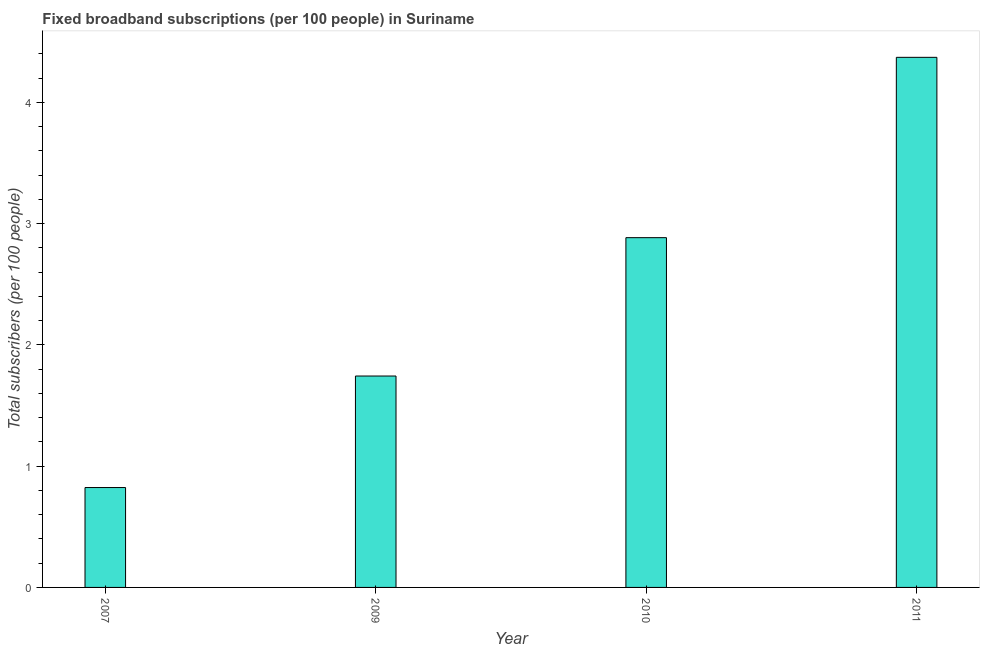Does the graph contain grids?
Your answer should be very brief. No. What is the title of the graph?
Your response must be concise. Fixed broadband subscriptions (per 100 people) in Suriname. What is the label or title of the Y-axis?
Keep it short and to the point. Total subscribers (per 100 people). What is the total number of fixed broadband subscriptions in 2007?
Give a very brief answer. 0.82. Across all years, what is the maximum total number of fixed broadband subscriptions?
Keep it short and to the point. 4.37. Across all years, what is the minimum total number of fixed broadband subscriptions?
Give a very brief answer. 0.82. What is the sum of the total number of fixed broadband subscriptions?
Your response must be concise. 9.82. What is the difference between the total number of fixed broadband subscriptions in 2009 and 2011?
Offer a very short reply. -2.63. What is the average total number of fixed broadband subscriptions per year?
Offer a very short reply. 2.46. What is the median total number of fixed broadband subscriptions?
Your response must be concise. 2.31. In how many years, is the total number of fixed broadband subscriptions greater than 0.6 ?
Give a very brief answer. 4. Do a majority of the years between 2009 and 2011 (inclusive) have total number of fixed broadband subscriptions greater than 1.8 ?
Your answer should be very brief. Yes. What is the ratio of the total number of fixed broadband subscriptions in 2009 to that in 2011?
Ensure brevity in your answer.  0.4. Is the difference between the total number of fixed broadband subscriptions in 2007 and 2010 greater than the difference between any two years?
Provide a succinct answer. No. What is the difference between the highest and the second highest total number of fixed broadband subscriptions?
Your answer should be very brief. 1.49. What is the difference between the highest and the lowest total number of fixed broadband subscriptions?
Your answer should be very brief. 3.55. In how many years, is the total number of fixed broadband subscriptions greater than the average total number of fixed broadband subscriptions taken over all years?
Make the answer very short. 2. Are all the bars in the graph horizontal?
Provide a succinct answer. No. How many years are there in the graph?
Your answer should be very brief. 4. What is the Total subscribers (per 100 people) of 2007?
Keep it short and to the point. 0.82. What is the Total subscribers (per 100 people) of 2009?
Keep it short and to the point. 1.74. What is the Total subscribers (per 100 people) in 2010?
Your answer should be compact. 2.88. What is the Total subscribers (per 100 people) of 2011?
Ensure brevity in your answer.  4.37. What is the difference between the Total subscribers (per 100 people) in 2007 and 2009?
Make the answer very short. -0.92. What is the difference between the Total subscribers (per 100 people) in 2007 and 2010?
Your answer should be compact. -2.06. What is the difference between the Total subscribers (per 100 people) in 2007 and 2011?
Provide a succinct answer. -3.55. What is the difference between the Total subscribers (per 100 people) in 2009 and 2010?
Offer a terse response. -1.14. What is the difference between the Total subscribers (per 100 people) in 2009 and 2011?
Keep it short and to the point. -2.63. What is the difference between the Total subscribers (per 100 people) in 2010 and 2011?
Ensure brevity in your answer.  -1.49. What is the ratio of the Total subscribers (per 100 people) in 2007 to that in 2009?
Ensure brevity in your answer.  0.47. What is the ratio of the Total subscribers (per 100 people) in 2007 to that in 2010?
Provide a succinct answer. 0.29. What is the ratio of the Total subscribers (per 100 people) in 2007 to that in 2011?
Your answer should be very brief. 0.19. What is the ratio of the Total subscribers (per 100 people) in 2009 to that in 2010?
Keep it short and to the point. 0.6. What is the ratio of the Total subscribers (per 100 people) in 2009 to that in 2011?
Provide a succinct answer. 0.4. What is the ratio of the Total subscribers (per 100 people) in 2010 to that in 2011?
Give a very brief answer. 0.66. 